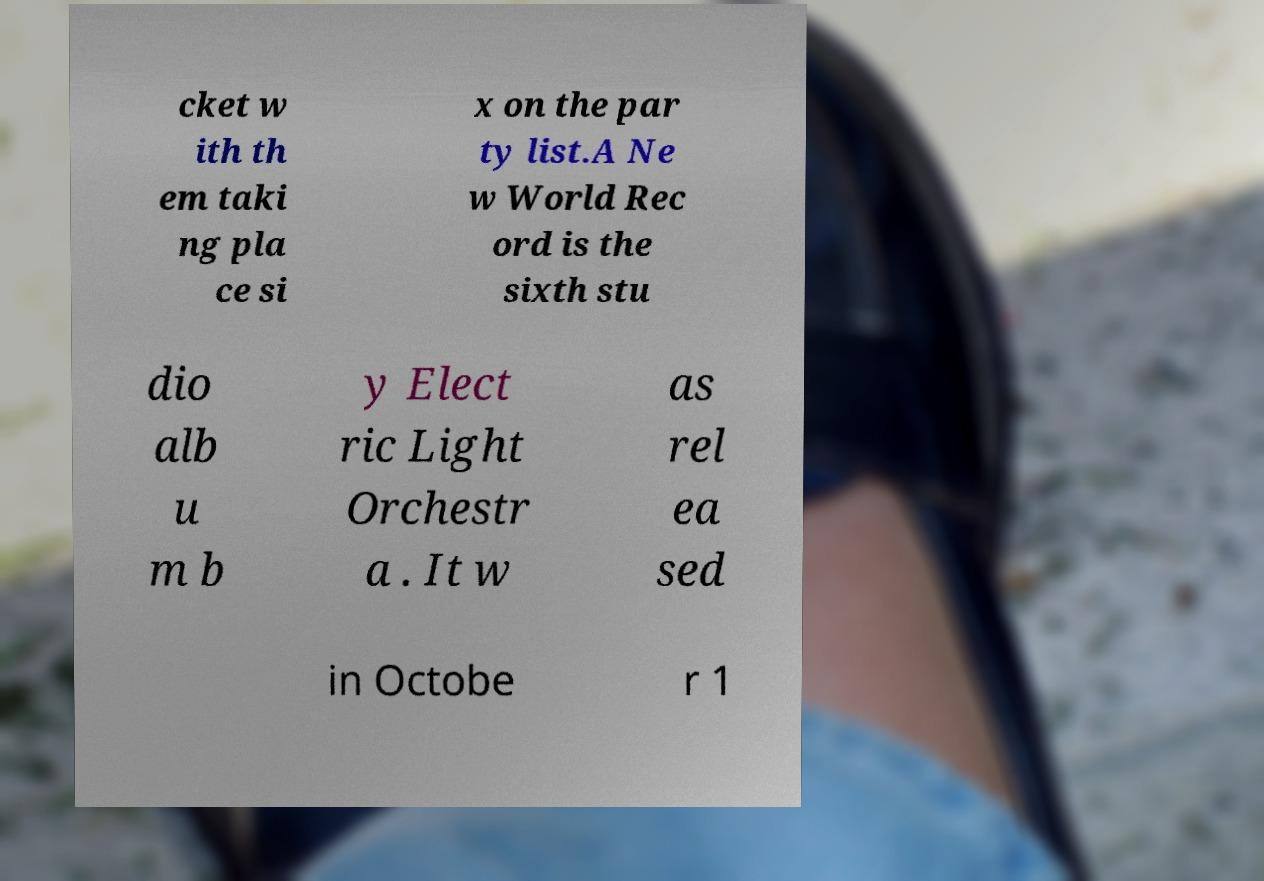Could you assist in decoding the text presented in this image and type it out clearly? cket w ith th em taki ng pla ce si x on the par ty list.A Ne w World Rec ord is the sixth stu dio alb u m b y Elect ric Light Orchestr a . It w as rel ea sed in Octobe r 1 